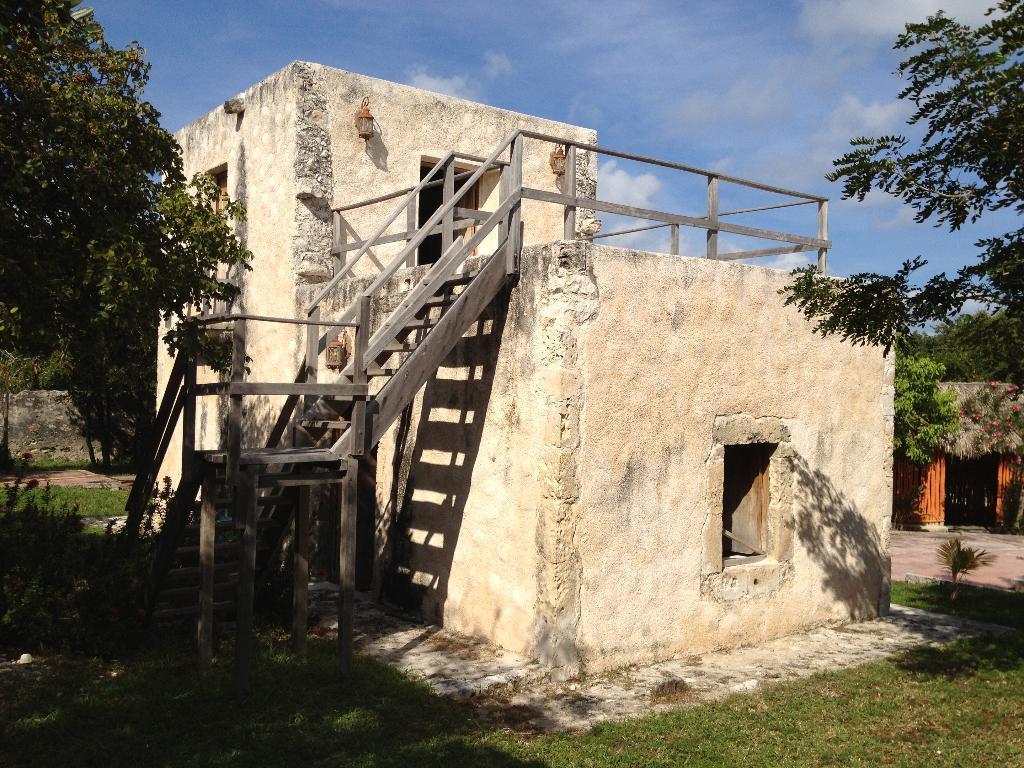In one or two sentences, can you explain what this image depicts? At the center of the image there are buildings, in front of the buildings there is the surface of the grass. In the background there are plants, trees and the sky. 